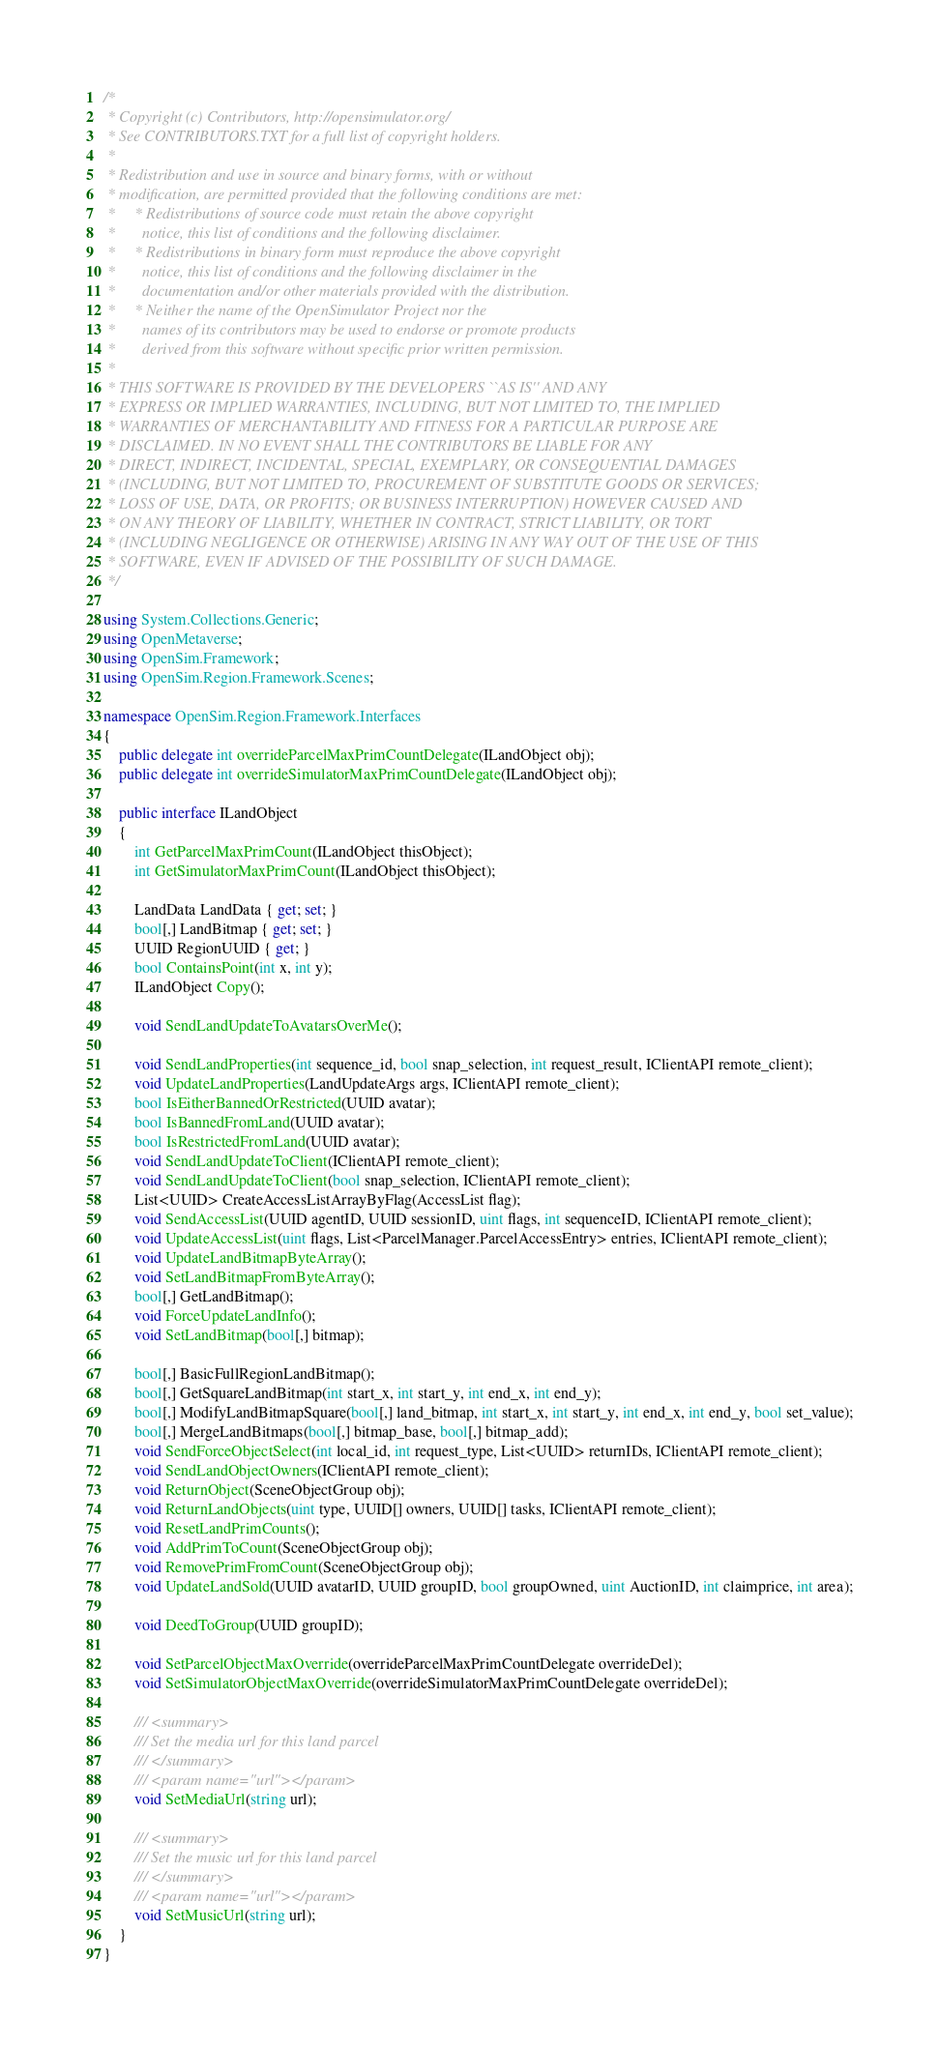<code> <loc_0><loc_0><loc_500><loc_500><_C#_>/*
 * Copyright (c) Contributors, http://opensimulator.org/
 * See CONTRIBUTORS.TXT for a full list of copyright holders.
 *
 * Redistribution and use in source and binary forms, with or without
 * modification, are permitted provided that the following conditions are met:
 *     * Redistributions of source code must retain the above copyright
 *       notice, this list of conditions and the following disclaimer.
 *     * Redistributions in binary form must reproduce the above copyright
 *       notice, this list of conditions and the following disclaimer in the
 *       documentation and/or other materials provided with the distribution.
 *     * Neither the name of the OpenSimulator Project nor the
 *       names of its contributors may be used to endorse or promote products
 *       derived from this software without specific prior written permission.
 *
 * THIS SOFTWARE IS PROVIDED BY THE DEVELOPERS ``AS IS'' AND ANY
 * EXPRESS OR IMPLIED WARRANTIES, INCLUDING, BUT NOT LIMITED TO, THE IMPLIED
 * WARRANTIES OF MERCHANTABILITY AND FITNESS FOR A PARTICULAR PURPOSE ARE
 * DISCLAIMED. IN NO EVENT SHALL THE CONTRIBUTORS BE LIABLE FOR ANY
 * DIRECT, INDIRECT, INCIDENTAL, SPECIAL, EXEMPLARY, OR CONSEQUENTIAL DAMAGES
 * (INCLUDING, BUT NOT LIMITED TO, PROCUREMENT OF SUBSTITUTE GOODS OR SERVICES;
 * LOSS OF USE, DATA, OR PROFITS; OR BUSINESS INTERRUPTION) HOWEVER CAUSED AND
 * ON ANY THEORY OF LIABILITY, WHETHER IN CONTRACT, STRICT LIABILITY, OR TORT
 * (INCLUDING NEGLIGENCE OR OTHERWISE) ARISING IN ANY WAY OUT OF THE USE OF THIS
 * SOFTWARE, EVEN IF ADVISED OF THE POSSIBILITY OF SUCH DAMAGE.
 */

using System.Collections.Generic;
using OpenMetaverse;
using OpenSim.Framework;
using OpenSim.Region.Framework.Scenes;

namespace OpenSim.Region.Framework.Interfaces
{
    public delegate int overrideParcelMaxPrimCountDelegate(ILandObject obj);
    public delegate int overrideSimulatorMaxPrimCountDelegate(ILandObject obj);

    public interface ILandObject
    {
        int GetParcelMaxPrimCount(ILandObject thisObject);
        int GetSimulatorMaxPrimCount(ILandObject thisObject);

        LandData LandData { get; set; }
        bool[,] LandBitmap { get; set; }
        UUID RegionUUID { get; }
        bool ContainsPoint(int x, int y);
        ILandObject Copy();

        void SendLandUpdateToAvatarsOverMe();

        void SendLandProperties(int sequence_id, bool snap_selection, int request_result, IClientAPI remote_client);
        void UpdateLandProperties(LandUpdateArgs args, IClientAPI remote_client);
        bool IsEitherBannedOrRestricted(UUID avatar);
        bool IsBannedFromLand(UUID avatar);
        bool IsRestrictedFromLand(UUID avatar);
        void SendLandUpdateToClient(IClientAPI remote_client);
        void SendLandUpdateToClient(bool snap_selection, IClientAPI remote_client);
        List<UUID> CreateAccessListArrayByFlag(AccessList flag);
        void SendAccessList(UUID agentID, UUID sessionID, uint flags, int sequenceID, IClientAPI remote_client);
        void UpdateAccessList(uint flags, List<ParcelManager.ParcelAccessEntry> entries, IClientAPI remote_client);
        void UpdateLandBitmapByteArray();
        void SetLandBitmapFromByteArray();
        bool[,] GetLandBitmap();
        void ForceUpdateLandInfo();
        void SetLandBitmap(bool[,] bitmap);

        bool[,] BasicFullRegionLandBitmap();
        bool[,] GetSquareLandBitmap(int start_x, int start_y, int end_x, int end_y);
        bool[,] ModifyLandBitmapSquare(bool[,] land_bitmap, int start_x, int start_y, int end_x, int end_y, bool set_value);
        bool[,] MergeLandBitmaps(bool[,] bitmap_base, bool[,] bitmap_add);
        void SendForceObjectSelect(int local_id, int request_type, List<UUID> returnIDs, IClientAPI remote_client);
        void SendLandObjectOwners(IClientAPI remote_client);
        void ReturnObject(SceneObjectGroup obj);
        void ReturnLandObjects(uint type, UUID[] owners, UUID[] tasks, IClientAPI remote_client);
        void ResetLandPrimCounts();
        void AddPrimToCount(SceneObjectGroup obj);
        void RemovePrimFromCount(SceneObjectGroup obj);
        void UpdateLandSold(UUID avatarID, UUID groupID, bool groupOwned, uint AuctionID, int claimprice, int area);

        void DeedToGroup(UUID groupID);

        void SetParcelObjectMaxOverride(overrideParcelMaxPrimCountDelegate overrideDel);
        void SetSimulatorObjectMaxOverride(overrideSimulatorMaxPrimCountDelegate overrideDel);

        /// <summary>
        /// Set the media url for this land parcel
        /// </summary>
        /// <param name="url"></param>
        void SetMediaUrl(string url);
        
        /// <summary>
        /// Set the music url for this land parcel
        /// </summary>
        /// <param name="url"></param>
        void SetMusicUrl(string url);
    }
}
</code> 